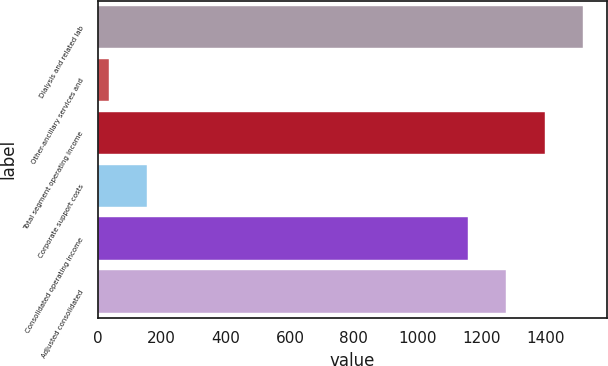<chart> <loc_0><loc_0><loc_500><loc_500><bar_chart><fcel>Dialysis and related lab<fcel>Other-ancillary services and<fcel>Total segment operating income<fcel>Corporate support costs<fcel>Consolidated operating income<fcel>Adjusted consolidated<nl><fcel>1515.6<fcel>34<fcel>1395.4<fcel>154.2<fcel>1155<fcel>1275.2<nl></chart> 